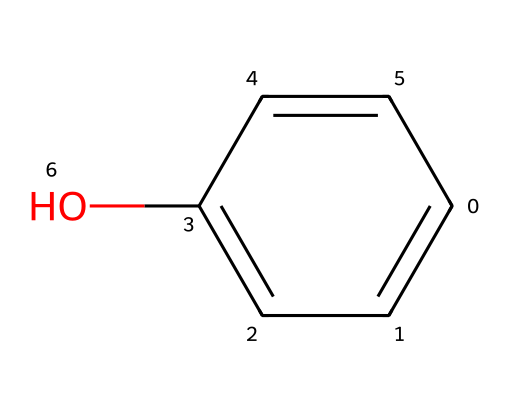What is the name of the chemical represented by this structure? The structure corresponds to a compound with a hydroxyl group (-OH) attached to a benzene ring. This specific compound is commonly known as phenol.
Answer: phenol How many carbon atoms are present in this structure? The SMILES representation reveals a benzene ring, which consists of six carbon atoms. Therefore, there are a total of six carbon atoms in the structure.
Answer: six What functional group is present in phenol? The presence of the hydroxy (-OH) group attached to the benzene ring identifies the functional group of this chemical as an alcohol.
Answer: alcohol Does phenol display any acidity? Analyzing the stability of the phenol when it loses a hydrogen ion shows that it can donate a proton to form phenoxide ion, indicating its weak acidity.
Answer: Yes How many hydrogen atoms are bonded to carbon atoms in phenol? Each of the six carbon atoms in the benzene ring is typically bonded to one hydrogen atom, but the carbon atom bonded to the hydroxyl group has one less hydrogen due to that bond. This results in five hydrogen atoms bonded to the carbon atoms.
Answer: five Is phenol an aromatic compound? The structure contains a benzene ring, which is a defining characteristic of aromatic compounds, confirming that phenol is indeed aromatic.
Answer: Yes 